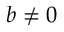Convert formula to latex. <formula><loc_0><loc_0><loc_500><loc_500>b \neq 0</formula> 